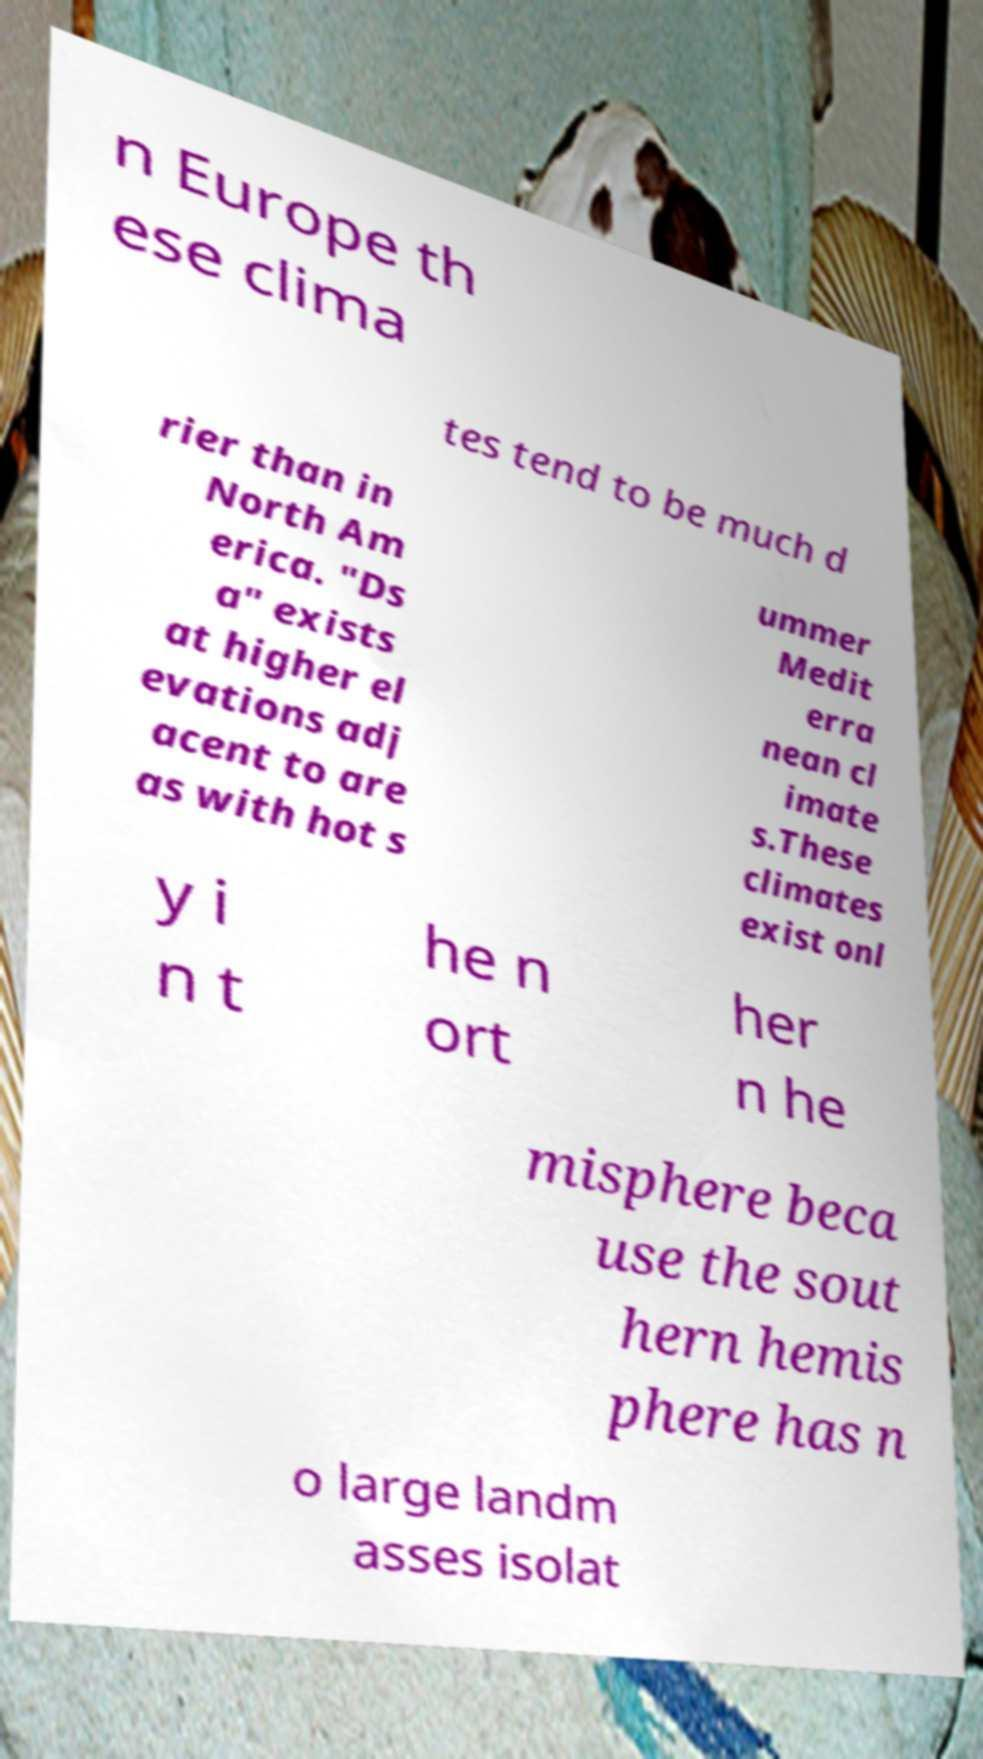I need the written content from this picture converted into text. Can you do that? n Europe th ese clima tes tend to be much d rier than in North Am erica. "Ds a" exists at higher el evations adj acent to are as with hot s ummer Medit erra nean cl imate s.These climates exist onl y i n t he n ort her n he misphere beca use the sout hern hemis phere has n o large landm asses isolat 